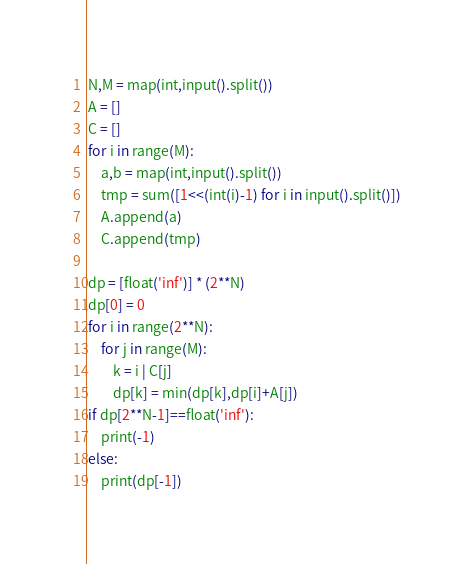<code> <loc_0><loc_0><loc_500><loc_500><_Python_>N,M = map(int,input().split())
A = []
C = []
for i in range(M):
    a,b = map(int,input().split())
    tmp = sum([1<<(int(i)-1) for i in input().split()])
    A.append(a)
    C.append(tmp)

dp = [float('inf')] * (2**N)
dp[0] = 0
for i in range(2**N):
    for j in range(M):
        k = i | C[j]
        dp[k] = min(dp[k],dp[i]+A[j])
if dp[2**N-1]==float('inf'):
    print(-1)
else:
    print(dp[-1])</code> 